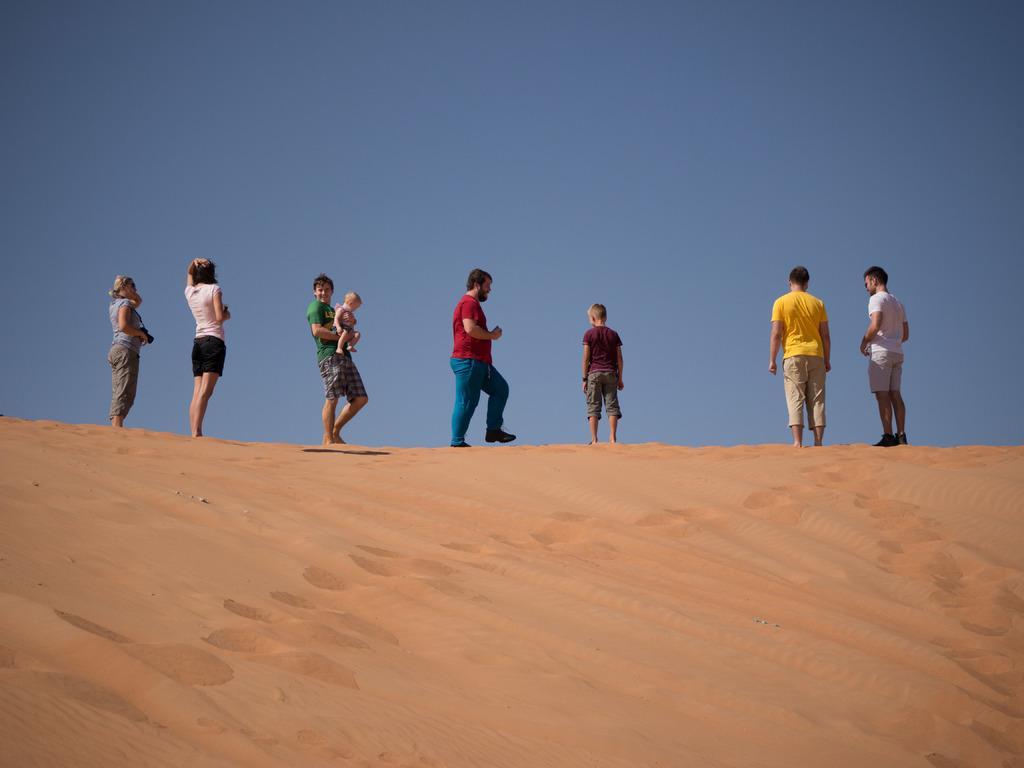How would you summarize this image in a sentence or two? In this picture I can see many people who are standing on the sand. At the top I can see the sky. 